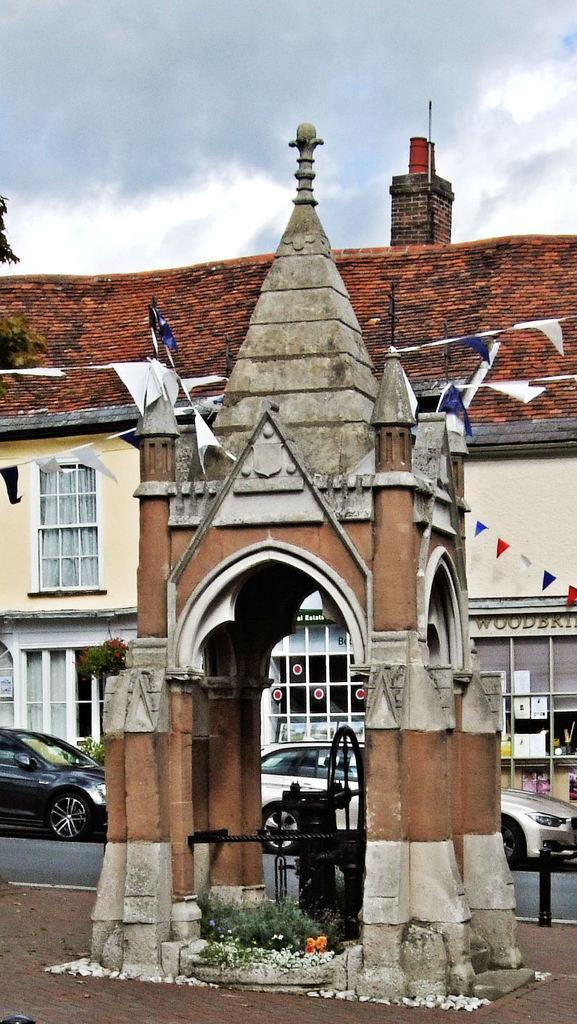Please provide a concise description of this image. In this image we can see houses, windows, there are cars on the road, there are plants, trees, there are some papers tied to the ropes, also we can see the sky. 